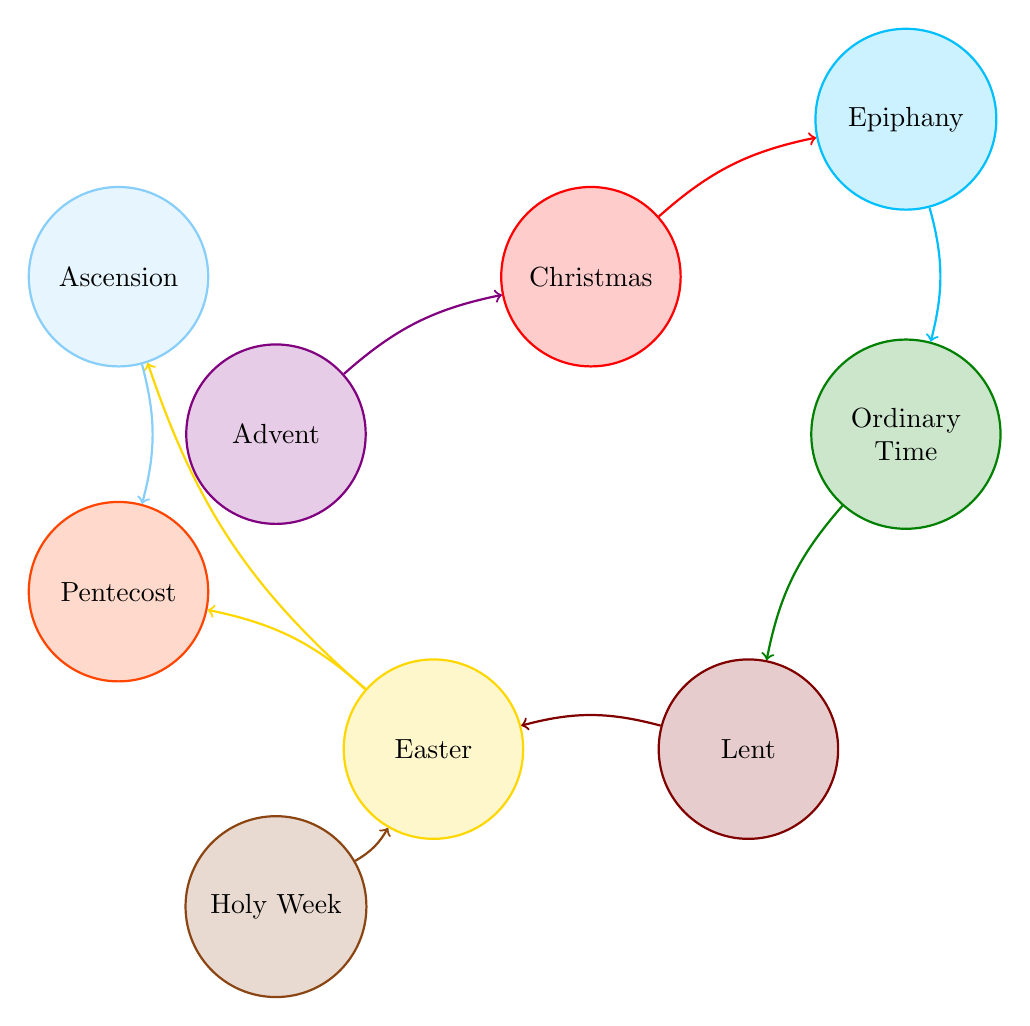What nodes are present in the diagram? The nodes represent various liturgical seasons and feast days, which are Advent, Christmas, Ordinary Time, Lent, Easter, Pentecost, Epiphany, Ascension, and Holy Week. Listing them directly gives the result.
Answer: Advent, Christmas, Ordinary Time, Lent, Easter, Pentecost, Epiphany, Ascension, Holy Week How many nodes are in the diagram? By counting the unique liturgical seasons and feast days in the list of nodes, we find there are nine nodes total.
Answer: 9 What is the link between Lent and Easter? The diagram shows a directed connection (link) indicating that Lent leads into Easter. This points to a direct interaction between the two liturgical periods.
Answer: Lent to Easter Which liturgical season comes immediately after Christmas? According to the link from the diagram, Epiphany follows Christmas in the sequence of Feast Days.
Answer: Epiphany How many links are there in total? To find this, count the number of relationships (links) connecting the nodes. The diagram has eight links connecting these liturgical seasons and days.
Answer: 8 What is the relationship between Easter and Pentecost? The diagram indicates a direct link, showing that Easter leads into Pentecost, which implies a continuation of the liturgical calendar.
Answer: Easter to Pentecost Which season precedes Ordinary Time? Looking at the directed links, Epiphany directly leads into Ordinary Time, which means it is the preceding season.
Answer: Epiphany Which feast day does Holy Week connect to? The diagram shows a direct link from Holy Week to Easter, highlighting the sequence in the liturgical calendar.
Answer: Easter How many seasons lead into Pentecost? By tracing the links, we find that two seasons (Easter and Ascension) lead into Pentecost, indicating multiple paths towards this feast day.
Answer: 2 